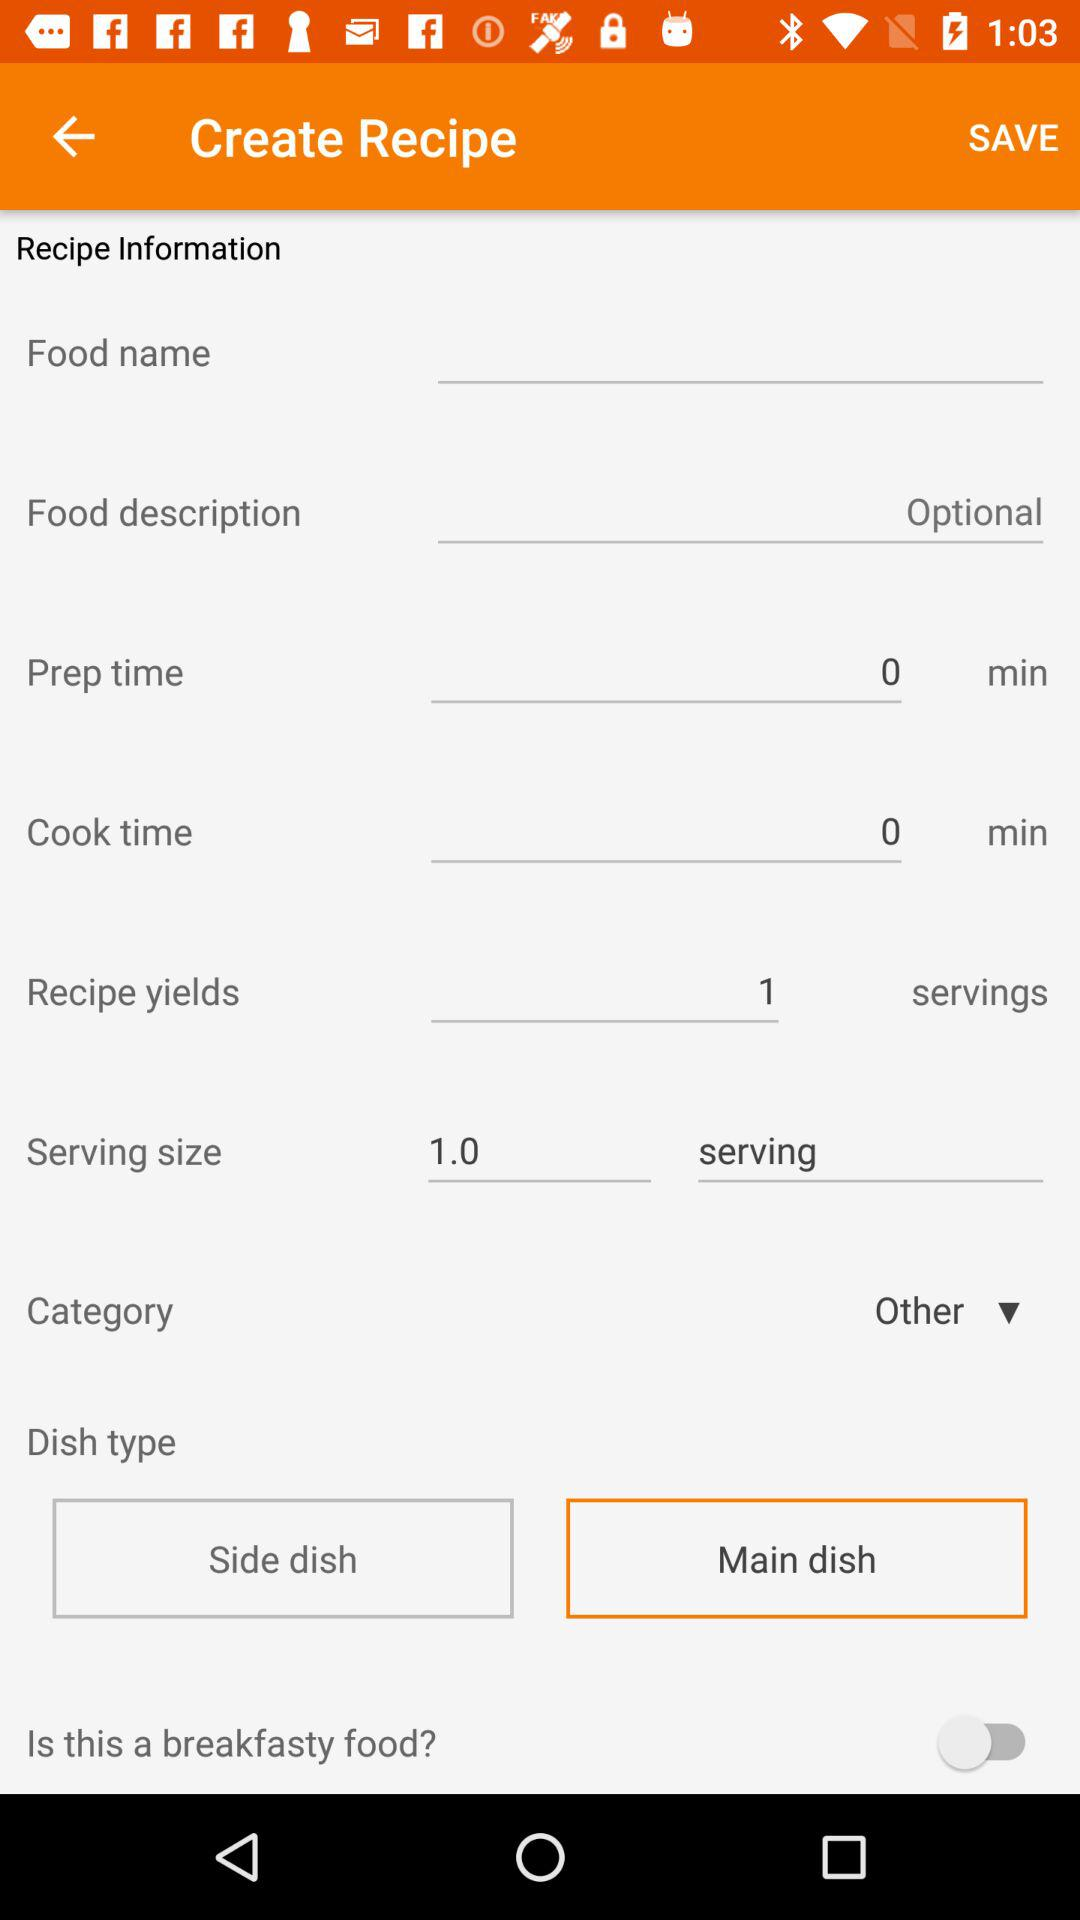What is the selected dish type? The selected dish type is the main dish. 